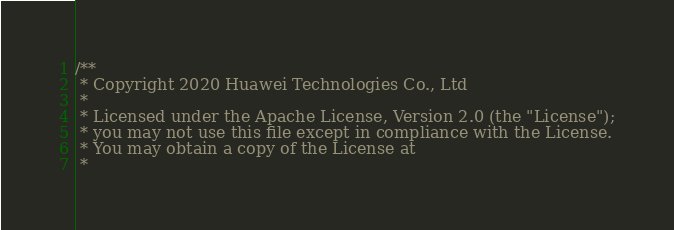<code> <loc_0><loc_0><loc_500><loc_500><_C_>/**
 * Copyright 2020 Huawei Technologies Co., Ltd
 *
 * Licensed under the Apache License, Version 2.0 (the "License");
 * you may not use this file except in compliance with the License.
 * You may obtain a copy of the License at
 *</code> 